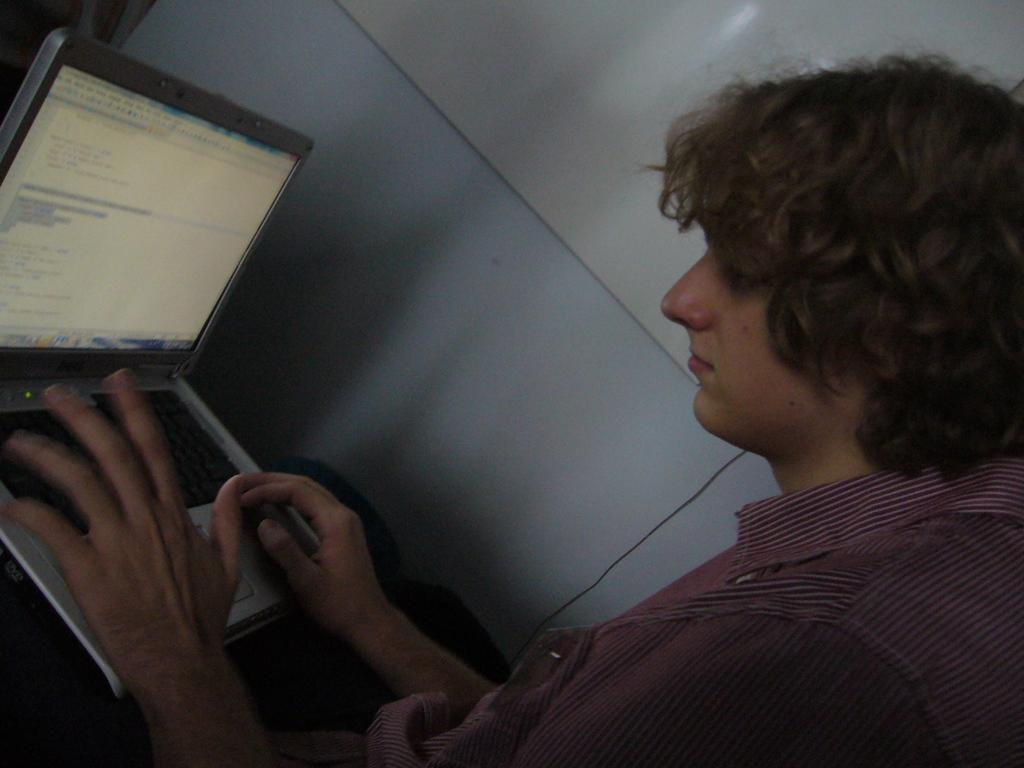Who is the main subject in the image? There is a boy in the image. What is the boy wearing? The boy is wearing a pink shirt. What is the boy doing in the image? The boy is sitting on a chair and working on a laptop. What can be seen in the background of the image? There is a white wall in the background of the image. What type of flock can be seen flying in the image? There is no flock of birds or any other animals visible in the image; it features a boy sitting on a chair and working on a laptop. 